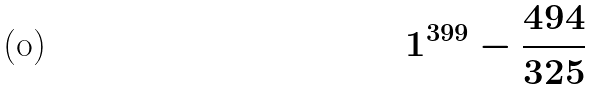<formula> <loc_0><loc_0><loc_500><loc_500>1 ^ { 3 9 9 } - \frac { 4 9 4 } { 3 2 5 }</formula> 